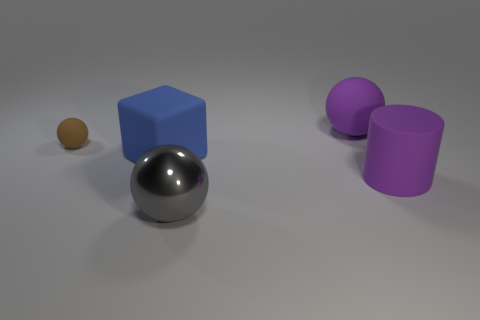What could be the purpose of this arrangement? This arrangement could be part of a computer graphics rendering test, designed to show how different shapes and materials interact with light, illustrate texture and reflectivity, or simply to serve as a visual display for aesthetic or educational purposes. 